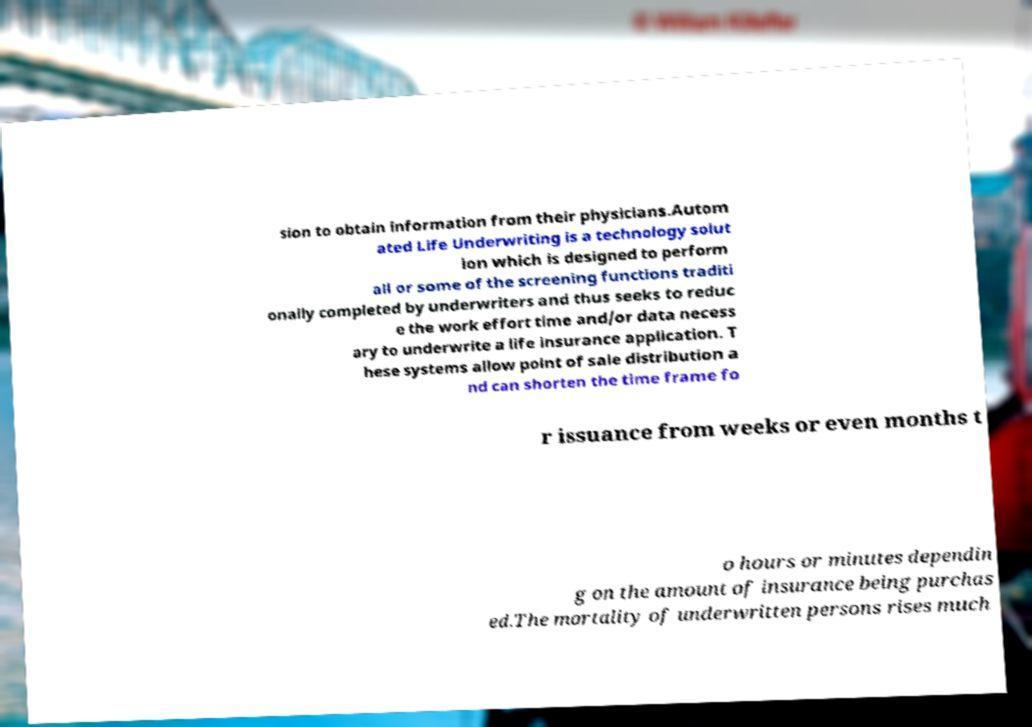Please identify and transcribe the text found in this image. sion to obtain information from their physicians.Autom ated Life Underwriting is a technology solut ion which is designed to perform all or some of the screening functions traditi onally completed by underwriters and thus seeks to reduc e the work effort time and/or data necess ary to underwrite a life insurance application. T hese systems allow point of sale distribution a nd can shorten the time frame fo r issuance from weeks or even months t o hours or minutes dependin g on the amount of insurance being purchas ed.The mortality of underwritten persons rises much 